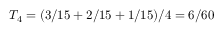Convert formula to latex. <formula><loc_0><loc_0><loc_500><loc_500>T _ { 4 } = ( 3 / 1 5 + 2 / 1 5 + 1 / 1 5 ) / 4 = 6 / 6 0</formula> 